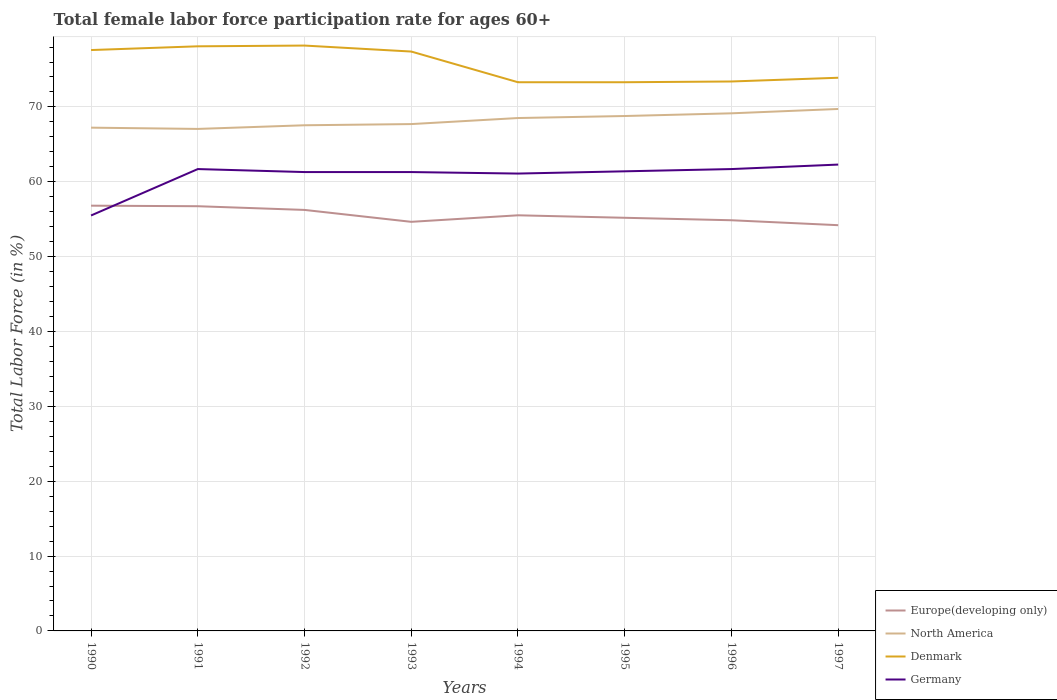How many different coloured lines are there?
Give a very brief answer. 4. Does the line corresponding to North America intersect with the line corresponding to Europe(developing only)?
Your answer should be compact. No. Across all years, what is the maximum female labor force participation rate in North America?
Make the answer very short. 67.06. What is the total female labor force participation rate in Europe(developing only) in the graph?
Give a very brief answer. 1.38. What is the difference between the highest and the second highest female labor force participation rate in Europe(developing only)?
Offer a terse response. 2.61. How many lines are there?
Ensure brevity in your answer.  4. What is the difference between two consecutive major ticks on the Y-axis?
Keep it short and to the point. 10. Are the values on the major ticks of Y-axis written in scientific E-notation?
Your answer should be compact. No. Where does the legend appear in the graph?
Make the answer very short. Bottom right. How are the legend labels stacked?
Offer a terse response. Vertical. What is the title of the graph?
Keep it short and to the point. Total female labor force participation rate for ages 60+. Does "French Polynesia" appear as one of the legend labels in the graph?
Offer a terse response. No. What is the Total Labor Force (in %) in Europe(developing only) in 1990?
Provide a succinct answer. 56.81. What is the Total Labor Force (in %) in North America in 1990?
Keep it short and to the point. 67.23. What is the Total Labor Force (in %) in Denmark in 1990?
Provide a short and direct response. 77.6. What is the Total Labor Force (in %) of Germany in 1990?
Your answer should be compact. 55.5. What is the Total Labor Force (in %) in Europe(developing only) in 1991?
Ensure brevity in your answer.  56.74. What is the Total Labor Force (in %) in North America in 1991?
Offer a terse response. 67.06. What is the Total Labor Force (in %) of Denmark in 1991?
Your response must be concise. 78.1. What is the Total Labor Force (in %) in Germany in 1991?
Your answer should be compact. 61.7. What is the Total Labor Force (in %) of Europe(developing only) in 1992?
Your response must be concise. 56.24. What is the Total Labor Force (in %) in North America in 1992?
Provide a succinct answer. 67.55. What is the Total Labor Force (in %) in Denmark in 1992?
Make the answer very short. 78.2. What is the Total Labor Force (in %) of Germany in 1992?
Your response must be concise. 61.3. What is the Total Labor Force (in %) in Europe(developing only) in 1993?
Provide a short and direct response. 54.65. What is the Total Labor Force (in %) of North America in 1993?
Make the answer very short. 67.71. What is the Total Labor Force (in %) in Denmark in 1993?
Your answer should be very brief. 77.4. What is the Total Labor Force (in %) in Germany in 1993?
Offer a very short reply. 61.3. What is the Total Labor Force (in %) in Europe(developing only) in 1994?
Make the answer very short. 55.52. What is the Total Labor Force (in %) of North America in 1994?
Provide a short and direct response. 68.52. What is the Total Labor Force (in %) in Denmark in 1994?
Offer a very short reply. 73.3. What is the Total Labor Force (in %) of Germany in 1994?
Provide a succinct answer. 61.1. What is the Total Labor Force (in %) of Europe(developing only) in 1995?
Provide a short and direct response. 55.19. What is the Total Labor Force (in %) of North America in 1995?
Keep it short and to the point. 68.79. What is the Total Labor Force (in %) of Denmark in 1995?
Ensure brevity in your answer.  73.3. What is the Total Labor Force (in %) of Germany in 1995?
Ensure brevity in your answer.  61.4. What is the Total Labor Force (in %) in Europe(developing only) in 1996?
Provide a short and direct response. 54.86. What is the Total Labor Force (in %) of North America in 1996?
Provide a short and direct response. 69.15. What is the Total Labor Force (in %) of Denmark in 1996?
Ensure brevity in your answer.  73.4. What is the Total Labor Force (in %) in Germany in 1996?
Your response must be concise. 61.7. What is the Total Labor Force (in %) in Europe(developing only) in 1997?
Your answer should be compact. 54.2. What is the Total Labor Force (in %) of North America in 1997?
Your answer should be compact. 69.73. What is the Total Labor Force (in %) of Denmark in 1997?
Provide a succinct answer. 73.9. What is the Total Labor Force (in %) of Germany in 1997?
Your answer should be very brief. 62.3. Across all years, what is the maximum Total Labor Force (in %) of Europe(developing only)?
Your answer should be very brief. 56.81. Across all years, what is the maximum Total Labor Force (in %) in North America?
Provide a short and direct response. 69.73. Across all years, what is the maximum Total Labor Force (in %) of Denmark?
Offer a very short reply. 78.2. Across all years, what is the maximum Total Labor Force (in %) in Germany?
Make the answer very short. 62.3. Across all years, what is the minimum Total Labor Force (in %) in Europe(developing only)?
Your response must be concise. 54.2. Across all years, what is the minimum Total Labor Force (in %) of North America?
Offer a very short reply. 67.06. Across all years, what is the minimum Total Labor Force (in %) in Denmark?
Your answer should be compact. 73.3. Across all years, what is the minimum Total Labor Force (in %) in Germany?
Make the answer very short. 55.5. What is the total Total Labor Force (in %) in Europe(developing only) in the graph?
Ensure brevity in your answer.  444.22. What is the total Total Labor Force (in %) in North America in the graph?
Your answer should be very brief. 545.74. What is the total Total Labor Force (in %) in Denmark in the graph?
Provide a short and direct response. 605.2. What is the total Total Labor Force (in %) of Germany in the graph?
Ensure brevity in your answer.  486.3. What is the difference between the Total Labor Force (in %) in Europe(developing only) in 1990 and that in 1991?
Keep it short and to the point. 0.07. What is the difference between the Total Labor Force (in %) in North America in 1990 and that in 1991?
Offer a terse response. 0.17. What is the difference between the Total Labor Force (in %) of Denmark in 1990 and that in 1991?
Your response must be concise. -0.5. What is the difference between the Total Labor Force (in %) of Germany in 1990 and that in 1991?
Make the answer very short. -6.2. What is the difference between the Total Labor Force (in %) in Europe(developing only) in 1990 and that in 1992?
Your answer should be compact. 0.57. What is the difference between the Total Labor Force (in %) in North America in 1990 and that in 1992?
Provide a short and direct response. -0.32. What is the difference between the Total Labor Force (in %) of Europe(developing only) in 1990 and that in 1993?
Your answer should be compact. 2.16. What is the difference between the Total Labor Force (in %) in North America in 1990 and that in 1993?
Your response must be concise. -0.48. What is the difference between the Total Labor Force (in %) of Denmark in 1990 and that in 1993?
Your response must be concise. 0.2. What is the difference between the Total Labor Force (in %) of Europe(developing only) in 1990 and that in 1994?
Your answer should be compact. 1.28. What is the difference between the Total Labor Force (in %) of North America in 1990 and that in 1994?
Your answer should be compact. -1.29. What is the difference between the Total Labor Force (in %) of Denmark in 1990 and that in 1994?
Provide a short and direct response. 4.3. What is the difference between the Total Labor Force (in %) in Europe(developing only) in 1990 and that in 1995?
Ensure brevity in your answer.  1.62. What is the difference between the Total Labor Force (in %) of North America in 1990 and that in 1995?
Make the answer very short. -1.56. What is the difference between the Total Labor Force (in %) of Europe(developing only) in 1990 and that in 1996?
Your answer should be compact. 1.95. What is the difference between the Total Labor Force (in %) in North America in 1990 and that in 1996?
Offer a very short reply. -1.91. What is the difference between the Total Labor Force (in %) of Denmark in 1990 and that in 1996?
Offer a terse response. 4.2. What is the difference between the Total Labor Force (in %) in Germany in 1990 and that in 1996?
Your response must be concise. -6.2. What is the difference between the Total Labor Force (in %) of Europe(developing only) in 1990 and that in 1997?
Provide a short and direct response. 2.61. What is the difference between the Total Labor Force (in %) in North America in 1990 and that in 1997?
Ensure brevity in your answer.  -2.49. What is the difference between the Total Labor Force (in %) of Germany in 1990 and that in 1997?
Ensure brevity in your answer.  -6.8. What is the difference between the Total Labor Force (in %) of Europe(developing only) in 1991 and that in 1992?
Your response must be concise. 0.49. What is the difference between the Total Labor Force (in %) of North America in 1991 and that in 1992?
Your response must be concise. -0.49. What is the difference between the Total Labor Force (in %) of Germany in 1991 and that in 1992?
Provide a short and direct response. 0.4. What is the difference between the Total Labor Force (in %) of Europe(developing only) in 1991 and that in 1993?
Ensure brevity in your answer.  2.08. What is the difference between the Total Labor Force (in %) of North America in 1991 and that in 1993?
Provide a short and direct response. -0.65. What is the difference between the Total Labor Force (in %) of Denmark in 1991 and that in 1993?
Your answer should be compact. 0.7. What is the difference between the Total Labor Force (in %) of Germany in 1991 and that in 1993?
Ensure brevity in your answer.  0.4. What is the difference between the Total Labor Force (in %) in Europe(developing only) in 1991 and that in 1994?
Provide a succinct answer. 1.21. What is the difference between the Total Labor Force (in %) in North America in 1991 and that in 1994?
Your answer should be very brief. -1.45. What is the difference between the Total Labor Force (in %) of Germany in 1991 and that in 1994?
Offer a very short reply. 0.6. What is the difference between the Total Labor Force (in %) of Europe(developing only) in 1991 and that in 1995?
Offer a very short reply. 1.55. What is the difference between the Total Labor Force (in %) in North America in 1991 and that in 1995?
Provide a succinct answer. -1.72. What is the difference between the Total Labor Force (in %) in Denmark in 1991 and that in 1995?
Ensure brevity in your answer.  4.8. What is the difference between the Total Labor Force (in %) in Europe(developing only) in 1991 and that in 1996?
Keep it short and to the point. 1.87. What is the difference between the Total Labor Force (in %) in North America in 1991 and that in 1996?
Ensure brevity in your answer.  -2.08. What is the difference between the Total Labor Force (in %) in Denmark in 1991 and that in 1996?
Offer a terse response. 4.7. What is the difference between the Total Labor Force (in %) of Germany in 1991 and that in 1996?
Offer a very short reply. 0. What is the difference between the Total Labor Force (in %) in Europe(developing only) in 1991 and that in 1997?
Ensure brevity in your answer.  2.53. What is the difference between the Total Labor Force (in %) of North America in 1991 and that in 1997?
Provide a succinct answer. -2.66. What is the difference between the Total Labor Force (in %) of Denmark in 1991 and that in 1997?
Provide a succinct answer. 4.2. What is the difference between the Total Labor Force (in %) in Germany in 1991 and that in 1997?
Offer a very short reply. -0.6. What is the difference between the Total Labor Force (in %) in Europe(developing only) in 1992 and that in 1993?
Give a very brief answer. 1.59. What is the difference between the Total Labor Force (in %) of North America in 1992 and that in 1993?
Give a very brief answer. -0.16. What is the difference between the Total Labor Force (in %) of Germany in 1992 and that in 1993?
Offer a terse response. 0. What is the difference between the Total Labor Force (in %) in Europe(developing only) in 1992 and that in 1994?
Make the answer very short. 0.72. What is the difference between the Total Labor Force (in %) of North America in 1992 and that in 1994?
Ensure brevity in your answer.  -0.97. What is the difference between the Total Labor Force (in %) in Europe(developing only) in 1992 and that in 1995?
Ensure brevity in your answer.  1.05. What is the difference between the Total Labor Force (in %) of North America in 1992 and that in 1995?
Keep it short and to the point. -1.24. What is the difference between the Total Labor Force (in %) of Denmark in 1992 and that in 1995?
Keep it short and to the point. 4.9. What is the difference between the Total Labor Force (in %) of Germany in 1992 and that in 1995?
Provide a short and direct response. -0.1. What is the difference between the Total Labor Force (in %) of Europe(developing only) in 1992 and that in 1996?
Provide a succinct answer. 1.38. What is the difference between the Total Labor Force (in %) in North America in 1992 and that in 1996?
Provide a short and direct response. -1.6. What is the difference between the Total Labor Force (in %) in Denmark in 1992 and that in 1996?
Offer a very short reply. 4.8. What is the difference between the Total Labor Force (in %) of Europe(developing only) in 1992 and that in 1997?
Your response must be concise. 2.04. What is the difference between the Total Labor Force (in %) of North America in 1992 and that in 1997?
Keep it short and to the point. -2.18. What is the difference between the Total Labor Force (in %) of Denmark in 1992 and that in 1997?
Ensure brevity in your answer.  4.3. What is the difference between the Total Labor Force (in %) in Germany in 1992 and that in 1997?
Provide a succinct answer. -1. What is the difference between the Total Labor Force (in %) of Europe(developing only) in 1993 and that in 1994?
Provide a short and direct response. -0.87. What is the difference between the Total Labor Force (in %) of North America in 1993 and that in 1994?
Give a very brief answer. -0.81. What is the difference between the Total Labor Force (in %) in Europe(developing only) in 1993 and that in 1995?
Offer a very short reply. -0.54. What is the difference between the Total Labor Force (in %) of North America in 1993 and that in 1995?
Your answer should be compact. -1.08. What is the difference between the Total Labor Force (in %) of Germany in 1993 and that in 1995?
Make the answer very short. -0.1. What is the difference between the Total Labor Force (in %) in Europe(developing only) in 1993 and that in 1996?
Provide a succinct answer. -0.21. What is the difference between the Total Labor Force (in %) of North America in 1993 and that in 1996?
Provide a succinct answer. -1.44. What is the difference between the Total Labor Force (in %) in Germany in 1993 and that in 1996?
Offer a very short reply. -0.4. What is the difference between the Total Labor Force (in %) in Europe(developing only) in 1993 and that in 1997?
Give a very brief answer. 0.45. What is the difference between the Total Labor Force (in %) in North America in 1993 and that in 1997?
Give a very brief answer. -2.02. What is the difference between the Total Labor Force (in %) of Denmark in 1993 and that in 1997?
Your response must be concise. 3.5. What is the difference between the Total Labor Force (in %) of Europe(developing only) in 1994 and that in 1995?
Your answer should be compact. 0.33. What is the difference between the Total Labor Force (in %) in North America in 1994 and that in 1995?
Provide a succinct answer. -0.27. What is the difference between the Total Labor Force (in %) of Europe(developing only) in 1994 and that in 1996?
Offer a very short reply. 0.66. What is the difference between the Total Labor Force (in %) in North America in 1994 and that in 1996?
Provide a succinct answer. -0.63. What is the difference between the Total Labor Force (in %) of Europe(developing only) in 1994 and that in 1997?
Make the answer very short. 1.32. What is the difference between the Total Labor Force (in %) of North America in 1994 and that in 1997?
Offer a very short reply. -1.21. What is the difference between the Total Labor Force (in %) in Europe(developing only) in 1995 and that in 1996?
Give a very brief answer. 0.33. What is the difference between the Total Labor Force (in %) of North America in 1995 and that in 1996?
Your response must be concise. -0.36. What is the difference between the Total Labor Force (in %) in Denmark in 1995 and that in 1996?
Your answer should be compact. -0.1. What is the difference between the Total Labor Force (in %) in Germany in 1995 and that in 1996?
Provide a succinct answer. -0.3. What is the difference between the Total Labor Force (in %) in Europe(developing only) in 1995 and that in 1997?
Your answer should be very brief. 0.99. What is the difference between the Total Labor Force (in %) of North America in 1995 and that in 1997?
Your answer should be compact. -0.94. What is the difference between the Total Labor Force (in %) of Denmark in 1995 and that in 1997?
Give a very brief answer. -0.6. What is the difference between the Total Labor Force (in %) in Germany in 1995 and that in 1997?
Offer a terse response. -0.9. What is the difference between the Total Labor Force (in %) of Europe(developing only) in 1996 and that in 1997?
Offer a terse response. 0.66. What is the difference between the Total Labor Force (in %) in North America in 1996 and that in 1997?
Make the answer very short. -0.58. What is the difference between the Total Labor Force (in %) of Denmark in 1996 and that in 1997?
Your answer should be compact. -0.5. What is the difference between the Total Labor Force (in %) of Germany in 1996 and that in 1997?
Your answer should be very brief. -0.6. What is the difference between the Total Labor Force (in %) in Europe(developing only) in 1990 and the Total Labor Force (in %) in North America in 1991?
Your answer should be compact. -10.25. What is the difference between the Total Labor Force (in %) in Europe(developing only) in 1990 and the Total Labor Force (in %) in Denmark in 1991?
Provide a short and direct response. -21.29. What is the difference between the Total Labor Force (in %) of Europe(developing only) in 1990 and the Total Labor Force (in %) of Germany in 1991?
Provide a short and direct response. -4.89. What is the difference between the Total Labor Force (in %) of North America in 1990 and the Total Labor Force (in %) of Denmark in 1991?
Your response must be concise. -10.87. What is the difference between the Total Labor Force (in %) of North America in 1990 and the Total Labor Force (in %) of Germany in 1991?
Give a very brief answer. 5.53. What is the difference between the Total Labor Force (in %) in Europe(developing only) in 1990 and the Total Labor Force (in %) in North America in 1992?
Provide a succinct answer. -10.74. What is the difference between the Total Labor Force (in %) of Europe(developing only) in 1990 and the Total Labor Force (in %) of Denmark in 1992?
Offer a terse response. -21.39. What is the difference between the Total Labor Force (in %) in Europe(developing only) in 1990 and the Total Labor Force (in %) in Germany in 1992?
Your answer should be very brief. -4.49. What is the difference between the Total Labor Force (in %) in North America in 1990 and the Total Labor Force (in %) in Denmark in 1992?
Keep it short and to the point. -10.97. What is the difference between the Total Labor Force (in %) in North America in 1990 and the Total Labor Force (in %) in Germany in 1992?
Keep it short and to the point. 5.93. What is the difference between the Total Labor Force (in %) in Denmark in 1990 and the Total Labor Force (in %) in Germany in 1992?
Provide a short and direct response. 16.3. What is the difference between the Total Labor Force (in %) in Europe(developing only) in 1990 and the Total Labor Force (in %) in North America in 1993?
Ensure brevity in your answer.  -10.9. What is the difference between the Total Labor Force (in %) in Europe(developing only) in 1990 and the Total Labor Force (in %) in Denmark in 1993?
Provide a short and direct response. -20.59. What is the difference between the Total Labor Force (in %) in Europe(developing only) in 1990 and the Total Labor Force (in %) in Germany in 1993?
Give a very brief answer. -4.49. What is the difference between the Total Labor Force (in %) of North America in 1990 and the Total Labor Force (in %) of Denmark in 1993?
Give a very brief answer. -10.17. What is the difference between the Total Labor Force (in %) of North America in 1990 and the Total Labor Force (in %) of Germany in 1993?
Your answer should be compact. 5.93. What is the difference between the Total Labor Force (in %) of Denmark in 1990 and the Total Labor Force (in %) of Germany in 1993?
Keep it short and to the point. 16.3. What is the difference between the Total Labor Force (in %) of Europe(developing only) in 1990 and the Total Labor Force (in %) of North America in 1994?
Your response must be concise. -11.71. What is the difference between the Total Labor Force (in %) in Europe(developing only) in 1990 and the Total Labor Force (in %) in Denmark in 1994?
Your answer should be compact. -16.49. What is the difference between the Total Labor Force (in %) in Europe(developing only) in 1990 and the Total Labor Force (in %) in Germany in 1994?
Your response must be concise. -4.29. What is the difference between the Total Labor Force (in %) in North America in 1990 and the Total Labor Force (in %) in Denmark in 1994?
Offer a very short reply. -6.07. What is the difference between the Total Labor Force (in %) of North America in 1990 and the Total Labor Force (in %) of Germany in 1994?
Your response must be concise. 6.13. What is the difference between the Total Labor Force (in %) in Denmark in 1990 and the Total Labor Force (in %) in Germany in 1994?
Provide a succinct answer. 16.5. What is the difference between the Total Labor Force (in %) of Europe(developing only) in 1990 and the Total Labor Force (in %) of North America in 1995?
Offer a terse response. -11.98. What is the difference between the Total Labor Force (in %) of Europe(developing only) in 1990 and the Total Labor Force (in %) of Denmark in 1995?
Make the answer very short. -16.49. What is the difference between the Total Labor Force (in %) in Europe(developing only) in 1990 and the Total Labor Force (in %) in Germany in 1995?
Offer a terse response. -4.59. What is the difference between the Total Labor Force (in %) in North America in 1990 and the Total Labor Force (in %) in Denmark in 1995?
Make the answer very short. -6.07. What is the difference between the Total Labor Force (in %) in North America in 1990 and the Total Labor Force (in %) in Germany in 1995?
Your response must be concise. 5.83. What is the difference between the Total Labor Force (in %) in Denmark in 1990 and the Total Labor Force (in %) in Germany in 1995?
Your answer should be very brief. 16.2. What is the difference between the Total Labor Force (in %) in Europe(developing only) in 1990 and the Total Labor Force (in %) in North America in 1996?
Your answer should be compact. -12.34. What is the difference between the Total Labor Force (in %) of Europe(developing only) in 1990 and the Total Labor Force (in %) of Denmark in 1996?
Offer a terse response. -16.59. What is the difference between the Total Labor Force (in %) in Europe(developing only) in 1990 and the Total Labor Force (in %) in Germany in 1996?
Offer a terse response. -4.89. What is the difference between the Total Labor Force (in %) in North America in 1990 and the Total Labor Force (in %) in Denmark in 1996?
Offer a very short reply. -6.17. What is the difference between the Total Labor Force (in %) of North America in 1990 and the Total Labor Force (in %) of Germany in 1996?
Provide a short and direct response. 5.53. What is the difference between the Total Labor Force (in %) in Europe(developing only) in 1990 and the Total Labor Force (in %) in North America in 1997?
Keep it short and to the point. -12.92. What is the difference between the Total Labor Force (in %) of Europe(developing only) in 1990 and the Total Labor Force (in %) of Denmark in 1997?
Give a very brief answer. -17.09. What is the difference between the Total Labor Force (in %) of Europe(developing only) in 1990 and the Total Labor Force (in %) of Germany in 1997?
Keep it short and to the point. -5.49. What is the difference between the Total Labor Force (in %) of North America in 1990 and the Total Labor Force (in %) of Denmark in 1997?
Your answer should be compact. -6.67. What is the difference between the Total Labor Force (in %) of North America in 1990 and the Total Labor Force (in %) of Germany in 1997?
Make the answer very short. 4.93. What is the difference between the Total Labor Force (in %) of Denmark in 1990 and the Total Labor Force (in %) of Germany in 1997?
Offer a very short reply. 15.3. What is the difference between the Total Labor Force (in %) of Europe(developing only) in 1991 and the Total Labor Force (in %) of North America in 1992?
Provide a succinct answer. -10.81. What is the difference between the Total Labor Force (in %) of Europe(developing only) in 1991 and the Total Labor Force (in %) of Denmark in 1992?
Offer a terse response. -21.46. What is the difference between the Total Labor Force (in %) of Europe(developing only) in 1991 and the Total Labor Force (in %) of Germany in 1992?
Provide a succinct answer. -4.56. What is the difference between the Total Labor Force (in %) in North America in 1991 and the Total Labor Force (in %) in Denmark in 1992?
Ensure brevity in your answer.  -11.14. What is the difference between the Total Labor Force (in %) of North America in 1991 and the Total Labor Force (in %) of Germany in 1992?
Make the answer very short. 5.76. What is the difference between the Total Labor Force (in %) in Denmark in 1991 and the Total Labor Force (in %) in Germany in 1992?
Give a very brief answer. 16.8. What is the difference between the Total Labor Force (in %) in Europe(developing only) in 1991 and the Total Labor Force (in %) in North America in 1993?
Your response must be concise. -10.97. What is the difference between the Total Labor Force (in %) in Europe(developing only) in 1991 and the Total Labor Force (in %) in Denmark in 1993?
Give a very brief answer. -20.66. What is the difference between the Total Labor Force (in %) in Europe(developing only) in 1991 and the Total Labor Force (in %) in Germany in 1993?
Your response must be concise. -4.56. What is the difference between the Total Labor Force (in %) in North America in 1991 and the Total Labor Force (in %) in Denmark in 1993?
Your answer should be compact. -10.34. What is the difference between the Total Labor Force (in %) in North America in 1991 and the Total Labor Force (in %) in Germany in 1993?
Keep it short and to the point. 5.76. What is the difference between the Total Labor Force (in %) in Europe(developing only) in 1991 and the Total Labor Force (in %) in North America in 1994?
Your response must be concise. -11.78. What is the difference between the Total Labor Force (in %) in Europe(developing only) in 1991 and the Total Labor Force (in %) in Denmark in 1994?
Your response must be concise. -16.56. What is the difference between the Total Labor Force (in %) of Europe(developing only) in 1991 and the Total Labor Force (in %) of Germany in 1994?
Provide a succinct answer. -4.36. What is the difference between the Total Labor Force (in %) in North America in 1991 and the Total Labor Force (in %) in Denmark in 1994?
Give a very brief answer. -6.24. What is the difference between the Total Labor Force (in %) of North America in 1991 and the Total Labor Force (in %) of Germany in 1994?
Your answer should be very brief. 5.96. What is the difference between the Total Labor Force (in %) in Denmark in 1991 and the Total Labor Force (in %) in Germany in 1994?
Give a very brief answer. 17. What is the difference between the Total Labor Force (in %) in Europe(developing only) in 1991 and the Total Labor Force (in %) in North America in 1995?
Your answer should be very brief. -12.05. What is the difference between the Total Labor Force (in %) in Europe(developing only) in 1991 and the Total Labor Force (in %) in Denmark in 1995?
Provide a succinct answer. -16.56. What is the difference between the Total Labor Force (in %) in Europe(developing only) in 1991 and the Total Labor Force (in %) in Germany in 1995?
Provide a short and direct response. -4.66. What is the difference between the Total Labor Force (in %) in North America in 1991 and the Total Labor Force (in %) in Denmark in 1995?
Your response must be concise. -6.24. What is the difference between the Total Labor Force (in %) in North America in 1991 and the Total Labor Force (in %) in Germany in 1995?
Provide a short and direct response. 5.66. What is the difference between the Total Labor Force (in %) of Europe(developing only) in 1991 and the Total Labor Force (in %) of North America in 1996?
Your response must be concise. -12.41. What is the difference between the Total Labor Force (in %) in Europe(developing only) in 1991 and the Total Labor Force (in %) in Denmark in 1996?
Your answer should be compact. -16.66. What is the difference between the Total Labor Force (in %) of Europe(developing only) in 1991 and the Total Labor Force (in %) of Germany in 1996?
Offer a terse response. -4.96. What is the difference between the Total Labor Force (in %) in North America in 1991 and the Total Labor Force (in %) in Denmark in 1996?
Ensure brevity in your answer.  -6.34. What is the difference between the Total Labor Force (in %) of North America in 1991 and the Total Labor Force (in %) of Germany in 1996?
Offer a very short reply. 5.36. What is the difference between the Total Labor Force (in %) in Denmark in 1991 and the Total Labor Force (in %) in Germany in 1996?
Your answer should be very brief. 16.4. What is the difference between the Total Labor Force (in %) in Europe(developing only) in 1991 and the Total Labor Force (in %) in North America in 1997?
Provide a succinct answer. -12.99. What is the difference between the Total Labor Force (in %) of Europe(developing only) in 1991 and the Total Labor Force (in %) of Denmark in 1997?
Offer a very short reply. -17.16. What is the difference between the Total Labor Force (in %) of Europe(developing only) in 1991 and the Total Labor Force (in %) of Germany in 1997?
Ensure brevity in your answer.  -5.56. What is the difference between the Total Labor Force (in %) in North America in 1991 and the Total Labor Force (in %) in Denmark in 1997?
Ensure brevity in your answer.  -6.84. What is the difference between the Total Labor Force (in %) in North America in 1991 and the Total Labor Force (in %) in Germany in 1997?
Your answer should be compact. 4.76. What is the difference between the Total Labor Force (in %) in Europe(developing only) in 1992 and the Total Labor Force (in %) in North America in 1993?
Your answer should be compact. -11.47. What is the difference between the Total Labor Force (in %) of Europe(developing only) in 1992 and the Total Labor Force (in %) of Denmark in 1993?
Give a very brief answer. -21.16. What is the difference between the Total Labor Force (in %) in Europe(developing only) in 1992 and the Total Labor Force (in %) in Germany in 1993?
Your response must be concise. -5.06. What is the difference between the Total Labor Force (in %) of North America in 1992 and the Total Labor Force (in %) of Denmark in 1993?
Keep it short and to the point. -9.85. What is the difference between the Total Labor Force (in %) in North America in 1992 and the Total Labor Force (in %) in Germany in 1993?
Make the answer very short. 6.25. What is the difference between the Total Labor Force (in %) in Europe(developing only) in 1992 and the Total Labor Force (in %) in North America in 1994?
Ensure brevity in your answer.  -12.28. What is the difference between the Total Labor Force (in %) of Europe(developing only) in 1992 and the Total Labor Force (in %) of Denmark in 1994?
Your answer should be compact. -17.06. What is the difference between the Total Labor Force (in %) in Europe(developing only) in 1992 and the Total Labor Force (in %) in Germany in 1994?
Your response must be concise. -4.86. What is the difference between the Total Labor Force (in %) of North America in 1992 and the Total Labor Force (in %) of Denmark in 1994?
Your answer should be compact. -5.75. What is the difference between the Total Labor Force (in %) in North America in 1992 and the Total Labor Force (in %) in Germany in 1994?
Offer a terse response. 6.45. What is the difference between the Total Labor Force (in %) of Europe(developing only) in 1992 and the Total Labor Force (in %) of North America in 1995?
Provide a short and direct response. -12.55. What is the difference between the Total Labor Force (in %) of Europe(developing only) in 1992 and the Total Labor Force (in %) of Denmark in 1995?
Give a very brief answer. -17.06. What is the difference between the Total Labor Force (in %) in Europe(developing only) in 1992 and the Total Labor Force (in %) in Germany in 1995?
Ensure brevity in your answer.  -5.16. What is the difference between the Total Labor Force (in %) of North America in 1992 and the Total Labor Force (in %) of Denmark in 1995?
Your response must be concise. -5.75. What is the difference between the Total Labor Force (in %) in North America in 1992 and the Total Labor Force (in %) in Germany in 1995?
Your answer should be compact. 6.15. What is the difference between the Total Labor Force (in %) of Denmark in 1992 and the Total Labor Force (in %) of Germany in 1995?
Provide a succinct answer. 16.8. What is the difference between the Total Labor Force (in %) in Europe(developing only) in 1992 and the Total Labor Force (in %) in North America in 1996?
Offer a very short reply. -12.91. What is the difference between the Total Labor Force (in %) of Europe(developing only) in 1992 and the Total Labor Force (in %) of Denmark in 1996?
Make the answer very short. -17.16. What is the difference between the Total Labor Force (in %) of Europe(developing only) in 1992 and the Total Labor Force (in %) of Germany in 1996?
Provide a short and direct response. -5.46. What is the difference between the Total Labor Force (in %) of North America in 1992 and the Total Labor Force (in %) of Denmark in 1996?
Make the answer very short. -5.85. What is the difference between the Total Labor Force (in %) of North America in 1992 and the Total Labor Force (in %) of Germany in 1996?
Provide a succinct answer. 5.85. What is the difference between the Total Labor Force (in %) in Europe(developing only) in 1992 and the Total Labor Force (in %) in North America in 1997?
Your answer should be very brief. -13.49. What is the difference between the Total Labor Force (in %) in Europe(developing only) in 1992 and the Total Labor Force (in %) in Denmark in 1997?
Your response must be concise. -17.66. What is the difference between the Total Labor Force (in %) of Europe(developing only) in 1992 and the Total Labor Force (in %) of Germany in 1997?
Make the answer very short. -6.06. What is the difference between the Total Labor Force (in %) of North America in 1992 and the Total Labor Force (in %) of Denmark in 1997?
Give a very brief answer. -6.35. What is the difference between the Total Labor Force (in %) in North America in 1992 and the Total Labor Force (in %) in Germany in 1997?
Keep it short and to the point. 5.25. What is the difference between the Total Labor Force (in %) of Europe(developing only) in 1993 and the Total Labor Force (in %) of North America in 1994?
Ensure brevity in your answer.  -13.87. What is the difference between the Total Labor Force (in %) in Europe(developing only) in 1993 and the Total Labor Force (in %) in Denmark in 1994?
Ensure brevity in your answer.  -18.65. What is the difference between the Total Labor Force (in %) of Europe(developing only) in 1993 and the Total Labor Force (in %) of Germany in 1994?
Your answer should be compact. -6.45. What is the difference between the Total Labor Force (in %) of North America in 1993 and the Total Labor Force (in %) of Denmark in 1994?
Your response must be concise. -5.59. What is the difference between the Total Labor Force (in %) of North America in 1993 and the Total Labor Force (in %) of Germany in 1994?
Offer a very short reply. 6.61. What is the difference between the Total Labor Force (in %) in Europe(developing only) in 1993 and the Total Labor Force (in %) in North America in 1995?
Make the answer very short. -14.14. What is the difference between the Total Labor Force (in %) of Europe(developing only) in 1993 and the Total Labor Force (in %) of Denmark in 1995?
Give a very brief answer. -18.65. What is the difference between the Total Labor Force (in %) in Europe(developing only) in 1993 and the Total Labor Force (in %) in Germany in 1995?
Provide a short and direct response. -6.75. What is the difference between the Total Labor Force (in %) in North America in 1993 and the Total Labor Force (in %) in Denmark in 1995?
Make the answer very short. -5.59. What is the difference between the Total Labor Force (in %) of North America in 1993 and the Total Labor Force (in %) of Germany in 1995?
Give a very brief answer. 6.31. What is the difference between the Total Labor Force (in %) of Denmark in 1993 and the Total Labor Force (in %) of Germany in 1995?
Provide a short and direct response. 16. What is the difference between the Total Labor Force (in %) in Europe(developing only) in 1993 and the Total Labor Force (in %) in North America in 1996?
Your answer should be compact. -14.5. What is the difference between the Total Labor Force (in %) of Europe(developing only) in 1993 and the Total Labor Force (in %) of Denmark in 1996?
Ensure brevity in your answer.  -18.75. What is the difference between the Total Labor Force (in %) in Europe(developing only) in 1993 and the Total Labor Force (in %) in Germany in 1996?
Your response must be concise. -7.05. What is the difference between the Total Labor Force (in %) in North America in 1993 and the Total Labor Force (in %) in Denmark in 1996?
Keep it short and to the point. -5.69. What is the difference between the Total Labor Force (in %) in North America in 1993 and the Total Labor Force (in %) in Germany in 1996?
Offer a very short reply. 6.01. What is the difference between the Total Labor Force (in %) in Europe(developing only) in 1993 and the Total Labor Force (in %) in North America in 1997?
Your answer should be compact. -15.08. What is the difference between the Total Labor Force (in %) of Europe(developing only) in 1993 and the Total Labor Force (in %) of Denmark in 1997?
Provide a short and direct response. -19.25. What is the difference between the Total Labor Force (in %) in Europe(developing only) in 1993 and the Total Labor Force (in %) in Germany in 1997?
Give a very brief answer. -7.65. What is the difference between the Total Labor Force (in %) in North America in 1993 and the Total Labor Force (in %) in Denmark in 1997?
Offer a terse response. -6.19. What is the difference between the Total Labor Force (in %) of North America in 1993 and the Total Labor Force (in %) of Germany in 1997?
Ensure brevity in your answer.  5.41. What is the difference between the Total Labor Force (in %) in Europe(developing only) in 1994 and the Total Labor Force (in %) in North America in 1995?
Your response must be concise. -13.26. What is the difference between the Total Labor Force (in %) of Europe(developing only) in 1994 and the Total Labor Force (in %) of Denmark in 1995?
Give a very brief answer. -17.78. What is the difference between the Total Labor Force (in %) of Europe(developing only) in 1994 and the Total Labor Force (in %) of Germany in 1995?
Keep it short and to the point. -5.88. What is the difference between the Total Labor Force (in %) of North America in 1994 and the Total Labor Force (in %) of Denmark in 1995?
Your response must be concise. -4.78. What is the difference between the Total Labor Force (in %) in North America in 1994 and the Total Labor Force (in %) in Germany in 1995?
Your answer should be very brief. 7.12. What is the difference between the Total Labor Force (in %) of Europe(developing only) in 1994 and the Total Labor Force (in %) of North America in 1996?
Offer a very short reply. -13.62. What is the difference between the Total Labor Force (in %) of Europe(developing only) in 1994 and the Total Labor Force (in %) of Denmark in 1996?
Your answer should be compact. -17.88. What is the difference between the Total Labor Force (in %) of Europe(developing only) in 1994 and the Total Labor Force (in %) of Germany in 1996?
Provide a succinct answer. -6.18. What is the difference between the Total Labor Force (in %) in North America in 1994 and the Total Labor Force (in %) in Denmark in 1996?
Provide a succinct answer. -4.88. What is the difference between the Total Labor Force (in %) in North America in 1994 and the Total Labor Force (in %) in Germany in 1996?
Keep it short and to the point. 6.82. What is the difference between the Total Labor Force (in %) in Europe(developing only) in 1994 and the Total Labor Force (in %) in North America in 1997?
Provide a succinct answer. -14.2. What is the difference between the Total Labor Force (in %) in Europe(developing only) in 1994 and the Total Labor Force (in %) in Denmark in 1997?
Your answer should be compact. -18.38. What is the difference between the Total Labor Force (in %) in Europe(developing only) in 1994 and the Total Labor Force (in %) in Germany in 1997?
Your answer should be very brief. -6.78. What is the difference between the Total Labor Force (in %) of North America in 1994 and the Total Labor Force (in %) of Denmark in 1997?
Give a very brief answer. -5.38. What is the difference between the Total Labor Force (in %) of North America in 1994 and the Total Labor Force (in %) of Germany in 1997?
Give a very brief answer. 6.22. What is the difference between the Total Labor Force (in %) of Europe(developing only) in 1995 and the Total Labor Force (in %) of North America in 1996?
Your response must be concise. -13.96. What is the difference between the Total Labor Force (in %) of Europe(developing only) in 1995 and the Total Labor Force (in %) of Denmark in 1996?
Your answer should be compact. -18.21. What is the difference between the Total Labor Force (in %) of Europe(developing only) in 1995 and the Total Labor Force (in %) of Germany in 1996?
Your answer should be compact. -6.51. What is the difference between the Total Labor Force (in %) in North America in 1995 and the Total Labor Force (in %) in Denmark in 1996?
Give a very brief answer. -4.61. What is the difference between the Total Labor Force (in %) in North America in 1995 and the Total Labor Force (in %) in Germany in 1996?
Ensure brevity in your answer.  7.09. What is the difference between the Total Labor Force (in %) in Denmark in 1995 and the Total Labor Force (in %) in Germany in 1996?
Your answer should be very brief. 11.6. What is the difference between the Total Labor Force (in %) in Europe(developing only) in 1995 and the Total Labor Force (in %) in North America in 1997?
Provide a succinct answer. -14.54. What is the difference between the Total Labor Force (in %) of Europe(developing only) in 1995 and the Total Labor Force (in %) of Denmark in 1997?
Offer a very short reply. -18.71. What is the difference between the Total Labor Force (in %) of Europe(developing only) in 1995 and the Total Labor Force (in %) of Germany in 1997?
Your answer should be very brief. -7.11. What is the difference between the Total Labor Force (in %) of North America in 1995 and the Total Labor Force (in %) of Denmark in 1997?
Give a very brief answer. -5.11. What is the difference between the Total Labor Force (in %) of North America in 1995 and the Total Labor Force (in %) of Germany in 1997?
Offer a terse response. 6.49. What is the difference between the Total Labor Force (in %) in Denmark in 1995 and the Total Labor Force (in %) in Germany in 1997?
Give a very brief answer. 11. What is the difference between the Total Labor Force (in %) of Europe(developing only) in 1996 and the Total Labor Force (in %) of North America in 1997?
Offer a terse response. -14.86. What is the difference between the Total Labor Force (in %) in Europe(developing only) in 1996 and the Total Labor Force (in %) in Denmark in 1997?
Provide a short and direct response. -19.04. What is the difference between the Total Labor Force (in %) in Europe(developing only) in 1996 and the Total Labor Force (in %) in Germany in 1997?
Your answer should be compact. -7.44. What is the difference between the Total Labor Force (in %) of North America in 1996 and the Total Labor Force (in %) of Denmark in 1997?
Keep it short and to the point. -4.75. What is the difference between the Total Labor Force (in %) in North America in 1996 and the Total Labor Force (in %) in Germany in 1997?
Offer a very short reply. 6.85. What is the difference between the Total Labor Force (in %) in Denmark in 1996 and the Total Labor Force (in %) in Germany in 1997?
Your answer should be compact. 11.1. What is the average Total Labor Force (in %) in Europe(developing only) per year?
Make the answer very short. 55.53. What is the average Total Labor Force (in %) of North America per year?
Offer a very short reply. 68.22. What is the average Total Labor Force (in %) of Denmark per year?
Give a very brief answer. 75.65. What is the average Total Labor Force (in %) of Germany per year?
Your answer should be compact. 60.79. In the year 1990, what is the difference between the Total Labor Force (in %) of Europe(developing only) and Total Labor Force (in %) of North America?
Offer a very short reply. -10.42. In the year 1990, what is the difference between the Total Labor Force (in %) in Europe(developing only) and Total Labor Force (in %) in Denmark?
Provide a succinct answer. -20.79. In the year 1990, what is the difference between the Total Labor Force (in %) of Europe(developing only) and Total Labor Force (in %) of Germany?
Make the answer very short. 1.31. In the year 1990, what is the difference between the Total Labor Force (in %) in North America and Total Labor Force (in %) in Denmark?
Offer a terse response. -10.37. In the year 1990, what is the difference between the Total Labor Force (in %) of North America and Total Labor Force (in %) of Germany?
Offer a terse response. 11.73. In the year 1990, what is the difference between the Total Labor Force (in %) of Denmark and Total Labor Force (in %) of Germany?
Offer a terse response. 22.1. In the year 1991, what is the difference between the Total Labor Force (in %) of Europe(developing only) and Total Labor Force (in %) of North America?
Your answer should be compact. -10.33. In the year 1991, what is the difference between the Total Labor Force (in %) in Europe(developing only) and Total Labor Force (in %) in Denmark?
Your answer should be very brief. -21.36. In the year 1991, what is the difference between the Total Labor Force (in %) in Europe(developing only) and Total Labor Force (in %) in Germany?
Provide a succinct answer. -4.96. In the year 1991, what is the difference between the Total Labor Force (in %) in North America and Total Labor Force (in %) in Denmark?
Your answer should be very brief. -11.04. In the year 1991, what is the difference between the Total Labor Force (in %) in North America and Total Labor Force (in %) in Germany?
Give a very brief answer. 5.36. In the year 1992, what is the difference between the Total Labor Force (in %) in Europe(developing only) and Total Labor Force (in %) in North America?
Offer a terse response. -11.31. In the year 1992, what is the difference between the Total Labor Force (in %) of Europe(developing only) and Total Labor Force (in %) of Denmark?
Keep it short and to the point. -21.96. In the year 1992, what is the difference between the Total Labor Force (in %) in Europe(developing only) and Total Labor Force (in %) in Germany?
Offer a very short reply. -5.06. In the year 1992, what is the difference between the Total Labor Force (in %) in North America and Total Labor Force (in %) in Denmark?
Provide a succinct answer. -10.65. In the year 1992, what is the difference between the Total Labor Force (in %) of North America and Total Labor Force (in %) of Germany?
Provide a succinct answer. 6.25. In the year 1993, what is the difference between the Total Labor Force (in %) in Europe(developing only) and Total Labor Force (in %) in North America?
Make the answer very short. -13.06. In the year 1993, what is the difference between the Total Labor Force (in %) in Europe(developing only) and Total Labor Force (in %) in Denmark?
Your answer should be very brief. -22.75. In the year 1993, what is the difference between the Total Labor Force (in %) of Europe(developing only) and Total Labor Force (in %) of Germany?
Offer a terse response. -6.65. In the year 1993, what is the difference between the Total Labor Force (in %) of North America and Total Labor Force (in %) of Denmark?
Provide a short and direct response. -9.69. In the year 1993, what is the difference between the Total Labor Force (in %) of North America and Total Labor Force (in %) of Germany?
Ensure brevity in your answer.  6.41. In the year 1993, what is the difference between the Total Labor Force (in %) of Denmark and Total Labor Force (in %) of Germany?
Your answer should be very brief. 16.1. In the year 1994, what is the difference between the Total Labor Force (in %) of Europe(developing only) and Total Labor Force (in %) of North America?
Your answer should be compact. -12.99. In the year 1994, what is the difference between the Total Labor Force (in %) of Europe(developing only) and Total Labor Force (in %) of Denmark?
Ensure brevity in your answer.  -17.78. In the year 1994, what is the difference between the Total Labor Force (in %) of Europe(developing only) and Total Labor Force (in %) of Germany?
Ensure brevity in your answer.  -5.58. In the year 1994, what is the difference between the Total Labor Force (in %) in North America and Total Labor Force (in %) in Denmark?
Your answer should be very brief. -4.78. In the year 1994, what is the difference between the Total Labor Force (in %) in North America and Total Labor Force (in %) in Germany?
Your answer should be compact. 7.42. In the year 1995, what is the difference between the Total Labor Force (in %) in Europe(developing only) and Total Labor Force (in %) in North America?
Provide a succinct answer. -13.6. In the year 1995, what is the difference between the Total Labor Force (in %) in Europe(developing only) and Total Labor Force (in %) in Denmark?
Keep it short and to the point. -18.11. In the year 1995, what is the difference between the Total Labor Force (in %) of Europe(developing only) and Total Labor Force (in %) of Germany?
Provide a short and direct response. -6.21. In the year 1995, what is the difference between the Total Labor Force (in %) of North America and Total Labor Force (in %) of Denmark?
Offer a very short reply. -4.51. In the year 1995, what is the difference between the Total Labor Force (in %) in North America and Total Labor Force (in %) in Germany?
Provide a succinct answer. 7.39. In the year 1996, what is the difference between the Total Labor Force (in %) of Europe(developing only) and Total Labor Force (in %) of North America?
Your answer should be compact. -14.28. In the year 1996, what is the difference between the Total Labor Force (in %) in Europe(developing only) and Total Labor Force (in %) in Denmark?
Provide a short and direct response. -18.54. In the year 1996, what is the difference between the Total Labor Force (in %) in Europe(developing only) and Total Labor Force (in %) in Germany?
Your answer should be compact. -6.84. In the year 1996, what is the difference between the Total Labor Force (in %) in North America and Total Labor Force (in %) in Denmark?
Provide a succinct answer. -4.25. In the year 1996, what is the difference between the Total Labor Force (in %) in North America and Total Labor Force (in %) in Germany?
Give a very brief answer. 7.45. In the year 1997, what is the difference between the Total Labor Force (in %) in Europe(developing only) and Total Labor Force (in %) in North America?
Your answer should be very brief. -15.52. In the year 1997, what is the difference between the Total Labor Force (in %) in Europe(developing only) and Total Labor Force (in %) in Denmark?
Your response must be concise. -19.7. In the year 1997, what is the difference between the Total Labor Force (in %) of Europe(developing only) and Total Labor Force (in %) of Germany?
Give a very brief answer. -8.1. In the year 1997, what is the difference between the Total Labor Force (in %) in North America and Total Labor Force (in %) in Denmark?
Provide a short and direct response. -4.17. In the year 1997, what is the difference between the Total Labor Force (in %) of North America and Total Labor Force (in %) of Germany?
Your answer should be compact. 7.43. What is the ratio of the Total Labor Force (in %) in Europe(developing only) in 1990 to that in 1991?
Offer a very short reply. 1. What is the ratio of the Total Labor Force (in %) of Germany in 1990 to that in 1991?
Provide a succinct answer. 0.9. What is the ratio of the Total Labor Force (in %) in Denmark in 1990 to that in 1992?
Provide a short and direct response. 0.99. What is the ratio of the Total Labor Force (in %) in Germany in 1990 to that in 1992?
Your answer should be very brief. 0.91. What is the ratio of the Total Labor Force (in %) in Europe(developing only) in 1990 to that in 1993?
Keep it short and to the point. 1.04. What is the ratio of the Total Labor Force (in %) in Germany in 1990 to that in 1993?
Provide a short and direct response. 0.91. What is the ratio of the Total Labor Force (in %) in Europe(developing only) in 1990 to that in 1994?
Your response must be concise. 1.02. What is the ratio of the Total Labor Force (in %) in North America in 1990 to that in 1994?
Your answer should be very brief. 0.98. What is the ratio of the Total Labor Force (in %) in Denmark in 1990 to that in 1994?
Give a very brief answer. 1.06. What is the ratio of the Total Labor Force (in %) of Germany in 1990 to that in 1994?
Your answer should be very brief. 0.91. What is the ratio of the Total Labor Force (in %) of Europe(developing only) in 1990 to that in 1995?
Keep it short and to the point. 1.03. What is the ratio of the Total Labor Force (in %) of North America in 1990 to that in 1995?
Offer a terse response. 0.98. What is the ratio of the Total Labor Force (in %) in Denmark in 1990 to that in 1995?
Ensure brevity in your answer.  1.06. What is the ratio of the Total Labor Force (in %) in Germany in 1990 to that in 1995?
Ensure brevity in your answer.  0.9. What is the ratio of the Total Labor Force (in %) in Europe(developing only) in 1990 to that in 1996?
Offer a very short reply. 1.04. What is the ratio of the Total Labor Force (in %) of North America in 1990 to that in 1996?
Your response must be concise. 0.97. What is the ratio of the Total Labor Force (in %) of Denmark in 1990 to that in 1996?
Your answer should be compact. 1.06. What is the ratio of the Total Labor Force (in %) of Germany in 1990 to that in 1996?
Your answer should be compact. 0.9. What is the ratio of the Total Labor Force (in %) of Europe(developing only) in 1990 to that in 1997?
Offer a very short reply. 1.05. What is the ratio of the Total Labor Force (in %) in North America in 1990 to that in 1997?
Your response must be concise. 0.96. What is the ratio of the Total Labor Force (in %) of Denmark in 1990 to that in 1997?
Give a very brief answer. 1.05. What is the ratio of the Total Labor Force (in %) in Germany in 1990 to that in 1997?
Your answer should be very brief. 0.89. What is the ratio of the Total Labor Force (in %) of Europe(developing only) in 1991 to that in 1992?
Give a very brief answer. 1.01. What is the ratio of the Total Labor Force (in %) in Denmark in 1991 to that in 1992?
Your answer should be compact. 1. What is the ratio of the Total Labor Force (in %) in Germany in 1991 to that in 1992?
Your answer should be compact. 1.01. What is the ratio of the Total Labor Force (in %) in Europe(developing only) in 1991 to that in 1993?
Your answer should be compact. 1.04. What is the ratio of the Total Labor Force (in %) in Denmark in 1991 to that in 1993?
Give a very brief answer. 1.01. What is the ratio of the Total Labor Force (in %) of Europe(developing only) in 1991 to that in 1994?
Provide a succinct answer. 1.02. What is the ratio of the Total Labor Force (in %) in North America in 1991 to that in 1994?
Provide a succinct answer. 0.98. What is the ratio of the Total Labor Force (in %) in Denmark in 1991 to that in 1994?
Provide a short and direct response. 1.07. What is the ratio of the Total Labor Force (in %) of Germany in 1991 to that in 1994?
Provide a short and direct response. 1.01. What is the ratio of the Total Labor Force (in %) in Europe(developing only) in 1991 to that in 1995?
Offer a very short reply. 1.03. What is the ratio of the Total Labor Force (in %) of North America in 1991 to that in 1995?
Ensure brevity in your answer.  0.97. What is the ratio of the Total Labor Force (in %) in Denmark in 1991 to that in 1995?
Provide a short and direct response. 1.07. What is the ratio of the Total Labor Force (in %) of Germany in 1991 to that in 1995?
Provide a short and direct response. 1. What is the ratio of the Total Labor Force (in %) of Europe(developing only) in 1991 to that in 1996?
Ensure brevity in your answer.  1.03. What is the ratio of the Total Labor Force (in %) in North America in 1991 to that in 1996?
Give a very brief answer. 0.97. What is the ratio of the Total Labor Force (in %) in Denmark in 1991 to that in 1996?
Keep it short and to the point. 1.06. What is the ratio of the Total Labor Force (in %) in Europe(developing only) in 1991 to that in 1997?
Your answer should be compact. 1.05. What is the ratio of the Total Labor Force (in %) in North America in 1991 to that in 1997?
Ensure brevity in your answer.  0.96. What is the ratio of the Total Labor Force (in %) in Denmark in 1991 to that in 1997?
Provide a short and direct response. 1.06. What is the ratio of the Total Labor Force (in %) of Europe(developing only) in 1992 to that in 1993?
Offer a terse response. 1.03. What is the ratio of the Total Labor Force (in %) in Denmark in 1992 to that in 1993?
Provide a succinct answer. 1.01. What is the ratio of the Total Labor Force (in %) of Europe(developing only) in 1992 to that in 1994?
Offer a very short reply. 1.01. What is the ratio of the Total Labor Force (in %) in North America in 1992 to that in 1994?
Give a very brief answer. 0.99. What is the ratio of the Total Labor Force (in %) of Denmark in 1992 to that in 1994?
Ensure brevity in your answer.  1.07. What is the ratio of the Total Labor Force (in %) of Germany in 1992 to that in 1994?
Make the answer very short. 1. What is the ratio of the Total Labor Force (in %) in Denmark in 1992 to that in 1995?
Provide a succinct answer. 1.07. What is the ratio of the Total Labor Force (in %) of Europe(developing only) in 1992 to that in 1996?
Your response must be concise. 1.03. What is the ratio of the Total Labor Force (in %) in North America in 1992 to that in 1996?
Make the answer very short. 0.98. What is the ratio of the Total Labor Force (in %) in Denmark in 1992 to that in 1996?
Your answer should be compact. 1.07. What is the ratio of the Total Labor Force (in %) of Germany in 1992 to that in 1996?
Give a very brief answer. 0.99. What is the ratio of the Total Labor Force (in %) of Europe(developing only) in 1992 to that in 1997?
Offer a terse response. 1.04. What is the ratio of the Total Labor Force (in %) of North America in 1992 to that in 1997?
Your answer should be compact. 0.97. What is the ratio of the Total Labor Force (in %) of Denmark in 1992 to that in 1997?
Provide a succinct answer. 1.06. What is the ratio of the Total Labor Force (in %) in Germany in 1992 to that in 1997?
Give a very brief answer. 0.98. What is the ratio of the Total Labor Force (in %) in Europe(developing only) in 1993 to that in 1994?
Provide a short and direct response. 0.98. What is the ratio of the Total Labor Force (in %) of North America in 1993 to that in 1994?
Provide a short and direct response. 0.99. What is the ratio of the Total Labor Force (in %) of Denmark in 1993 to that in 1994?
Give a very brief answer. 1.06. What is the ratio of the Total Labor Force (in %) in Europe(developing only) in 1993 to that in 1995?
Your answer should be compact. 0.99. What is the ratio of the Total Labor Force (in %) in North America in 1993 to that in 1995?
Provide a succinct answer. 0.98. What is the ratio of the Total Labor Force (in %) of Denmark in 1993 to that in 1995?
Your response must be concise. 1.06. What is the ratio of the Total Labor Force (in %) in Europe(developing only) in 1993 to that in 1996?
Offer a very short reply. 1. What is the ratio of the Total Labor Force (in %) of North America in 1993 to that in 1996?
Provide a succinct answer. 0.98. What is the ratio of the Total Labor Force (in %) of Denmark in 1993 to that in 1996?
Offer a very short reply. 1.05. What is the ratio of the Total Labor Force (in %) in Europe(developing only) in 1993 to that in 1997?
Provide a short and direct response. 1.01. What is the ratio of the Total Labor Force (in %) of North America in 1993 to that in 1997?
Provide a short and direct response. 0.97. What is the ratio of the Total Labor Force (in %) of Denmark in 1993 to that in 1997?
Ensure brevity in your answer.  1.05. What is the ratio of the Total Labor Force (in %) of Germany in 1993 to that in 1997?
Offer a very short reply. 0.98. What is the ratio of the Total Labor Force (in %) of North America in 1994 to that in 1995?
Ensure brevity in your answer.  1. What is the ratio of the Total Labor Force (in %) in Germany in 1994 to that in 1995?
Offer a very short reply. 1. What is the ratio of the Total Labor Force (in %) in Europe(developing only) in 1994 to that in 1996?
Make the answer very short. 1.01. What is the ratio of the Total Labor Force (in %) of North America in 1994 to that in 1996?
Provide a short and direct response. 0.99. What is the ratio of the Total Labor Force (in %) of Germany in 1994 to that in 1996?
Offer a terse response. 0.99. What is the ratio of the Total Labor Force (in %) in Europe(developing only) in 1994 to that in 1997?
Provide a short and direct response. 1.02. What is the ratio of the Total Labor Force (in %) in North America in 1994 to that in 1997?
Provide a short and direct response. 0.98. What is the ratio of the Total Labor Force (in %) in Germany in 1994 to that in 1997?
Provide a succinct answer. 0.98. What is the ratio of the Total Labor Force (in %) of Europe(developing only) in 1995 to that in 1996?
Offer a terse response. 1.01. What is the ratio of the Total Labor Force (in %) of Denmark in 1995 to that in 1996?
Provide a short and direct response. 1. What is the ratio of the Total Labor Force (in %) in Europe(developing only) in 1995 to that in 1997?
Ensure brevity in your answer.  1.02. What is the ratio of the Total Labor Force (in %) of North America in 1995 to that in 1997?
Offer a very short reply. 0.99. What is the ratio of the Total Labor Force (in %) in Denmark in 1995 to that in 1997?
Offer a terse response. 0.99. What is the ratio of the Total Labor Force (in %) in Germany in 1995 to that in 1997?
Provide a succinct answer. 0.99. What is the ratio of the Total Labor Force (in %) in Europe(developing only) in 1996 to that in 1997?
Provide a succinct answer. 1.01. What is the ratio of the Total Labor Force (in %) in Germany in 1996 to that in 1997?
Provide a short and direct response. 0.99. What is the difference between the highest and the second highest Total Labor Force (in %) in Europe(developing only)?
Your answer should be compact. 0.07. What is the difference between the highest and the second highest Total Labor Force (in %) in North America?
Keep it short and to the point. 0.58. What is the difference between the highest and the second highest Total Labor Force (in %) of Denmark?
Give a very brief answer. 0.1. What is the difference between the highest and the lowest Total Labor Force (in %) of Europe(developing only)?
Offer a terse response. 2.61. What is the difference between the highest and the lowest Total Labor Force (in %) of North America?
Your answer should be very brief. 2.66. 